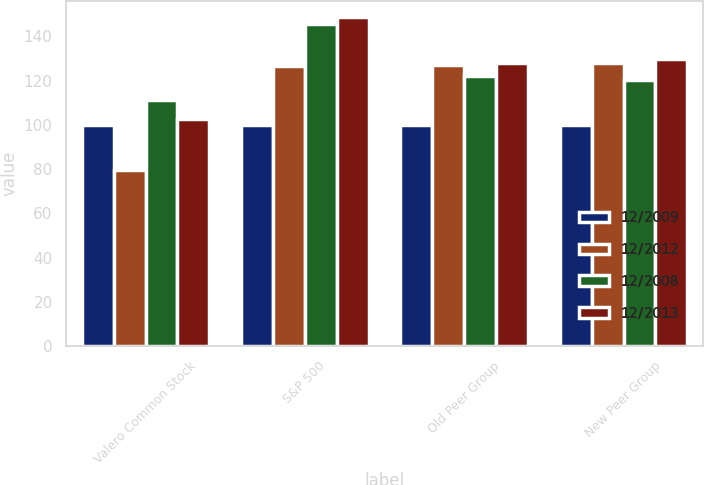<chart> <loc_0><loc_0><loc_500><loc_500><stacked_bar_chart><ecel><fcel>Valero Common Stock<fcel>S&P 500<fcel>Old Peer Group<fcel>New Peer Group<nl><fcel>12/2009<fcel>100<fcel>100<fcel>100<fcel>100<nl><fcel>12/2012<fcel>79.77<fcel>126.46<fcel>126.98<fcel>127.95<nl><fcel>12/2008<fcel>111.31<fcel>145.51<fcel>122.17<fcel>120.42<nl><fcel>12/2013<fcel>102.57<fcel>148.59<fcel>127.9<fcel>129.69<nl></chart> 